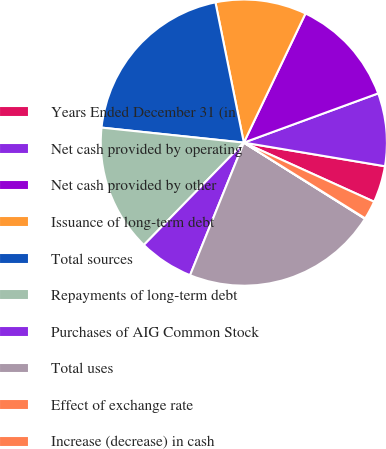Convert chart to OTSL. <chart><loc_0><loc_0><loc_500><loc_500><pie_chart><fcel>Years Ended December 31 (in<fcel>Net cash provided by operating<fcel>Net cash provided by other<fcel>Issuance of long-term debt<fcel>Total sources<fcel>Repayments of long-term debt<fcel>Purchases of AIG Common Stock<fcel>Total uses<fcel>Effect of exchange rate<fcel>Increase (decrease) in cash<nl><fcel>4.14%<fcel>8.23%<fcel>12.32%<fcel>10.27%<fcel>20.15%<fcel>14.36%<fcel>6.18%<fcel>22.2%<fcel>0.05%<fcel>2.1%<nl></chart> 